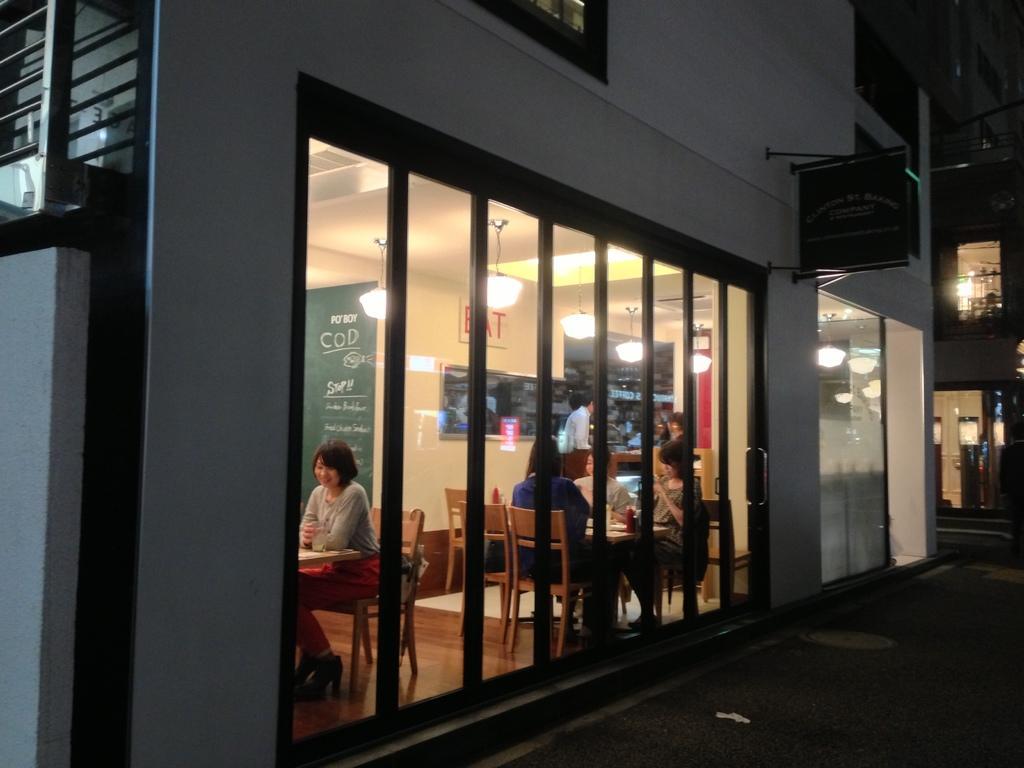In one or two sentences, can you explain what this image depicts? In this image, we can see few peoples are sat on the chair. Two tables are there, few items are placed on it. We can see glass door, lights, banners, boards. Few are standing here. And right side, there is a building and board here. Here fencing on left side, we can see wall. 